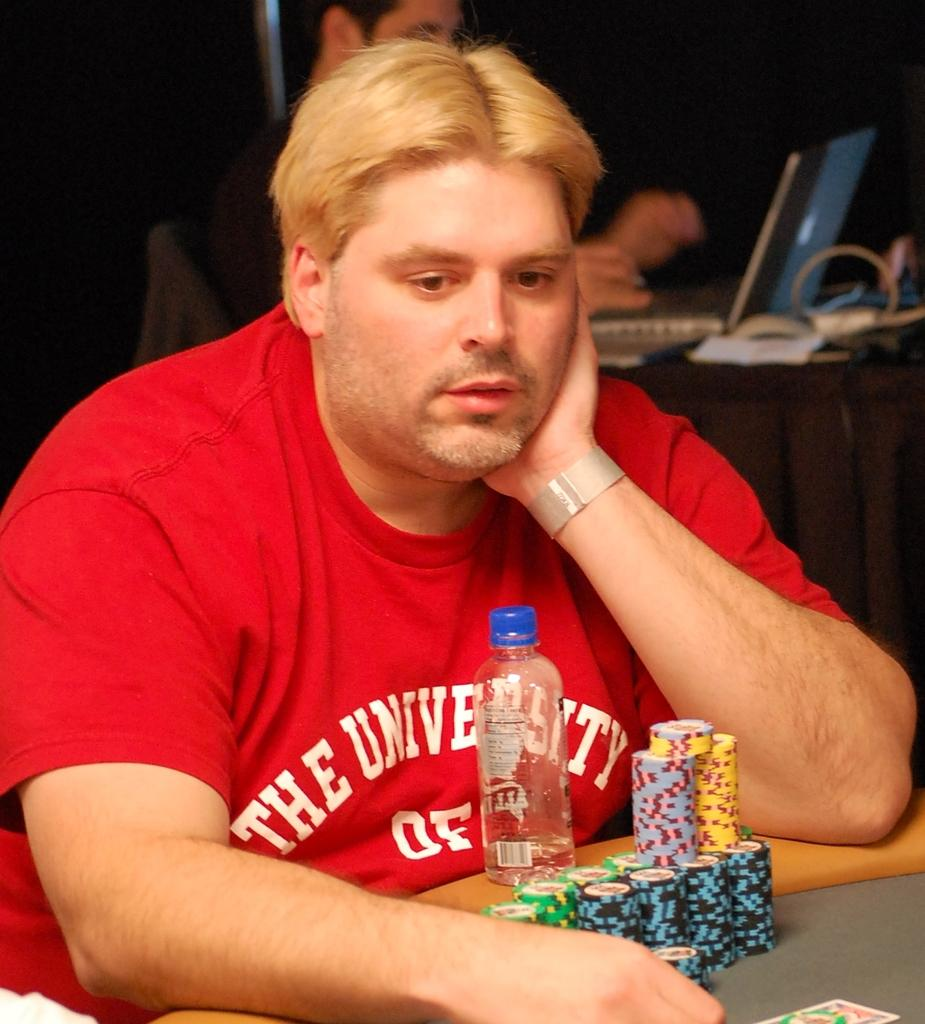Who is present in the image? There is a man in the image. What is the man wearing? The man is wearing a red t-shirt. Where is the man located in the image? The man is sitting in front of a table. What items can be seen on the table? There is a water bottle and coins on the table. How many dolls are sitting on the table with the man? There are no dolls present in the image; only a man, a water bottle, and coins can be seen on the table. 